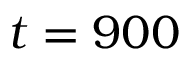Convert formula to latex. <formula><loc_0><loc_0><loc_500><loc_500>t = 9 0 0</formula> 